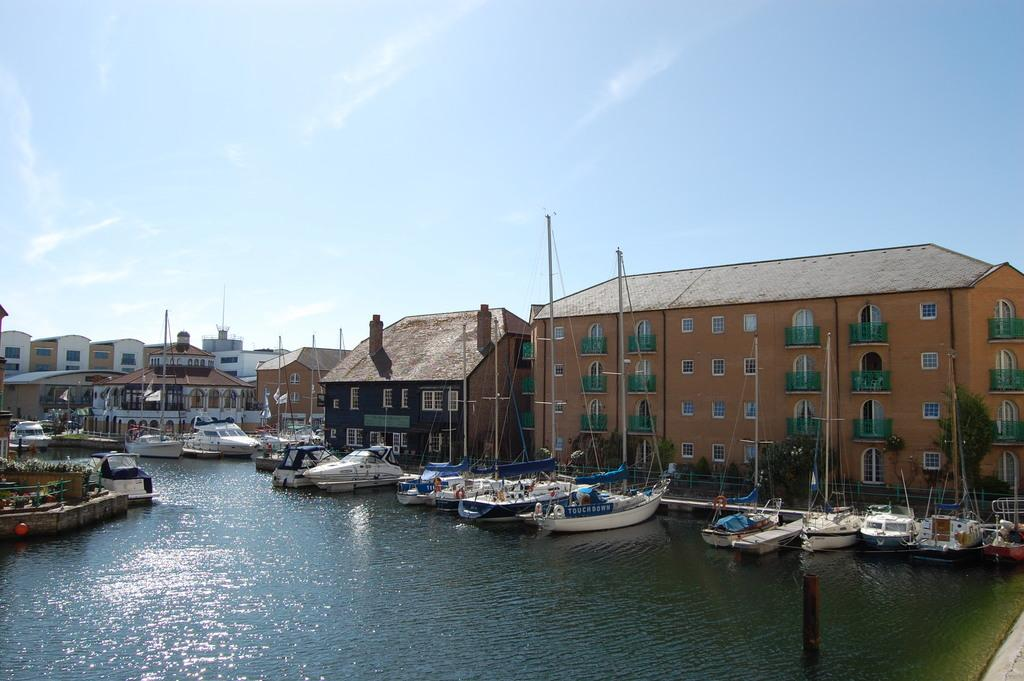What type of vehicles are in the image? There are boats in the image. Where are the boats located? The boats are on the sea. What can be seen in the background of the image? There are buildings in the background of the image. What type of silk is being used by the team in the image? There is no silk or team present in the image; it features boats on the sea with buildings in the background. 